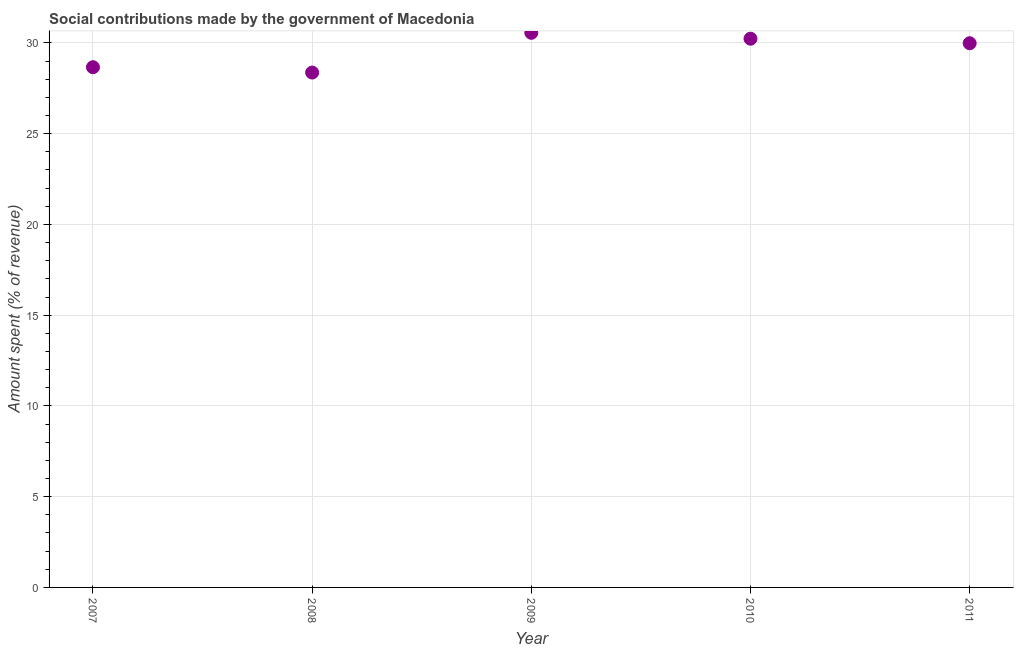What is the amount spent in making social contributions in 2010?
Your response must be concise. 30.23. Across all years, what is the maximum amount spent in making social contributions?
Your response must be concise. 30.56. Across all years, what is the minimum amount spent in making social contributions?
Your answer should be compact. 28.37. In which year was the amount spent in making social contributions minimum?
Provide a short and direct response. 2008. What is the sum of the amount spent in making social contributions?
Provide a succinct answer. 147.81. What is the difference between the amount spent in making social contributions in 2007 and 2011?
Provide a short and direct response. -1.32. What is the average amount spent in making social contributions per year?
Give a very brief answer. 29.56. What is the median amount spent in making social contributions?
Give a very brief answer. 29.98. In how many years, is the amount spent in making social contributions greater than 14 %?
Give a very brief answer. 5. Do a majority of the years between 2009 and 2008 (inclusive) have amount spent in making social contributions greater than 13 %?
Your answer should be compact. No. What is the ratio of the amount spent in making social contributions in 2008 to that in 2010?
Keep it short and to the point. 0.94. Is the amount spent in making social contributions in 2007 less than that in 2009?
Make the answer very short. Yes. What is the difference between the highest and the second highest amount spent in making social contributions?
Offer a very short reply. 0.32. Is the sum of the amount spent in making social contributions in 2009 and 2011 greater than the maximum amount spent in making social contributions across all years?
Offer a very short reply. Yes. What is the difference between the highest and the lowest amount spent in making social contributions?
Your answer should be compact. 2.19. What is the title of the graph?
Your answer should be compact. Social contributions made by the government of Macedonia. What is the label or title of the Y-axis?
Your response must be concise. Amount spent (% of revenue). What is the Amount spent (% of revenue) in 2007?
Provide a short and direct response. 28.66. What is the Amount spent (% of revenue) in 2008?
Ensure brevity in your answer.  28.37. What is the Amount spent (% of revenue) in 2009?
Give a very brief answer. 30.56. What is the Amount spent (% of revenue) in 2010?
Keep it short and to the point. 30.23. What is the Amount spent (% of revenue) in 2011?
Offer a terse response. 29.98. What is the difference between the Amount spent (% of revenue) in 2007 and 2008?
Offer a very short reply. 0.29. What is the difference between the Amount spent (% of revenue) in 2007 and 2009?
Keep it short and to the point. -1.9. What is the difference between the Amount spent (% of revenue) in 2007 and 2010?
Keep it short and to the point. -1.57. What is the difference between the Amount spent (% of revenue) in 2007 and 2011?
Keep it short and to the point. -1.32. What is the difference between the Amount spent (% of revenue) in 2008 and 2009?
Make the answer very short. -2.19. What is the difference between the Amount spent (% of revenue) in 2008 and 2010?
Your response must be concise. -1.86. What is the difference between the Amount spent (% of revenue) in 2008 and 2011?
Offer a very short reply. -1.62. What is the difference between the Amount spent (% of revenue) in 2009 and 2010?
Offer a terse response. 0.32. What is the difference between the Amount spent (% of revenue) in 2009 and 2011?
Your answer should be very brief. 0.57. What is the difference between the Amount spent (% of revenue) in 2010 and 2011?
Your answer should be compact. 0.25. What is the ratio of the Amount spent (% of revenue) in 2007 to that in 2008?
Your answer should be compact. 1.01. What is the ratio of the Amount spent (% of revenue) in 2007 to that in 2009?
Offer a very short reply. 0.94. What is the ratio of the Amount spent (% of revenue) in 2007 to that in 2010?
Ensure brevity in your answer.  0.95. What is the ratio of the Amount spent (% of revenue) in 2007 to that in 2011?
Ensure brevity in your answer.  0.96. What is the ratio of the Amount spent (% of revenue) in 2008 to that in 2009?
Your response must be concise. 0.93. What is the ratio of the Amount spent (% of revenue) in 2008 to that in 2010?
Your answer should be very brief. 0.94. What is the ratio of the Amount spent (% of revenue) in 2008 to that in 2011?
Offer a terse response. 0.95. What is the ratio of the Amount spent (% of revenue) in 2009 to that in 2010?
Ensure brevity in your answer.  1.01. 